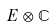<formula> <loc_0><loc_0><loc_500><loc_500>E \otimes \mathbb { C }</formula> 